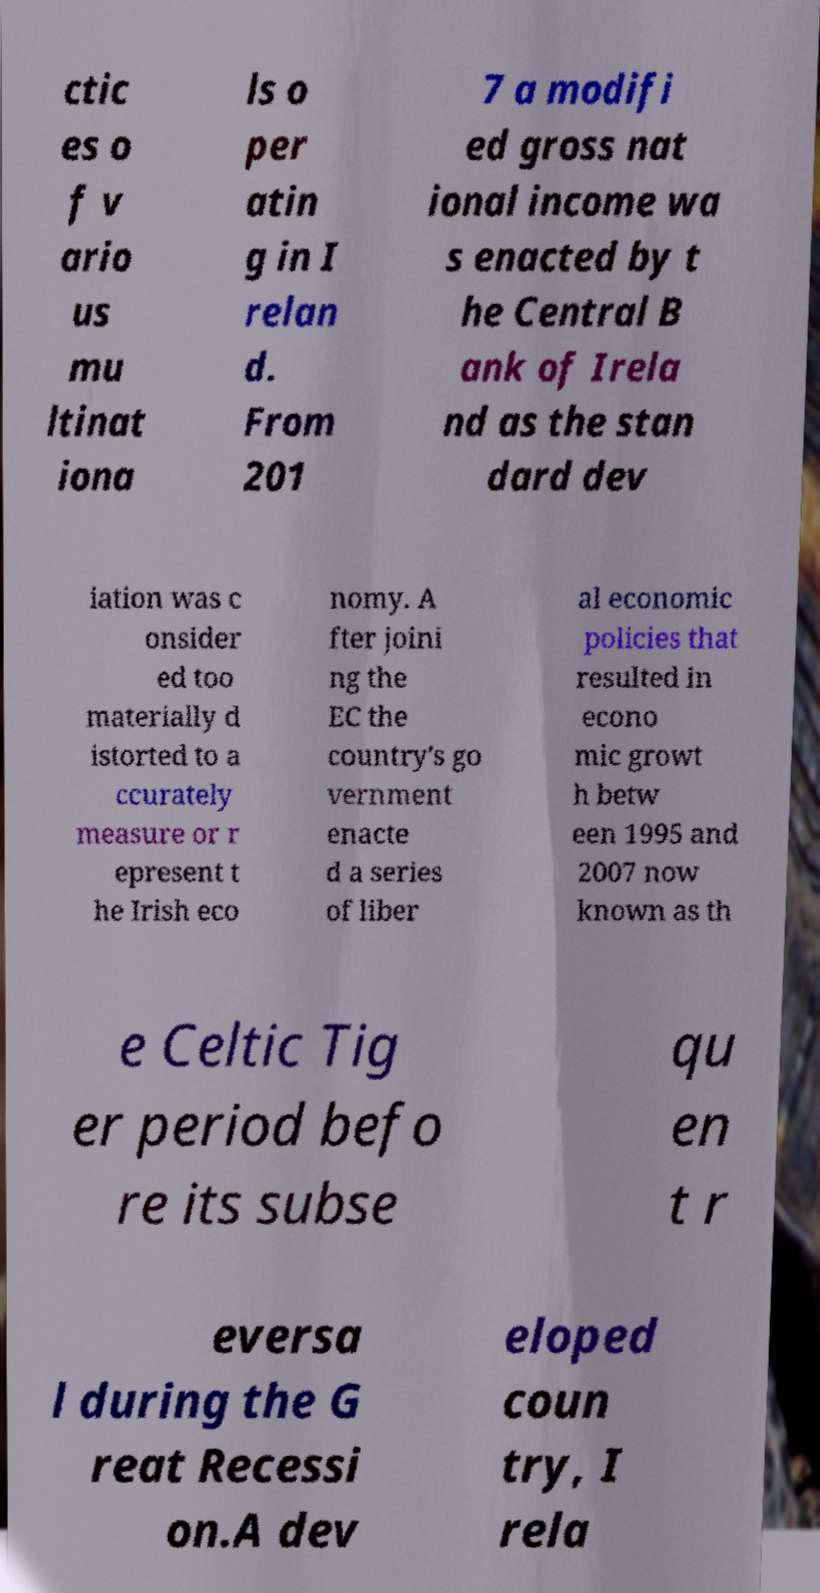Could you assist in decoding the text presented in this image and type it out clearly? ctic es o f v ario us mu ltinat iona ls o per atin g in I relan d. From 201 7 a modifi ed gross nat ional income wa s enacted by t he Central B ank of Irela nd as the stan dard dev iation was c onsider ed too materially d istorted to a ccurately measure or r epresent t he Irish eco nomy. A fter joini ng the EC the country's go vernment enacte d a series of liber al economic policies that resulted in econo mic growt h betw een 1995 and 2007 now known as th e Celtic Tig er period befo re its subse qu en t r eversa l during the G reat Recessi on.A dev eloped coun try, I rela 